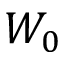<formula> <loc_0><loc_0><loc_500><loc_500>W _ { 0 }</formula> 